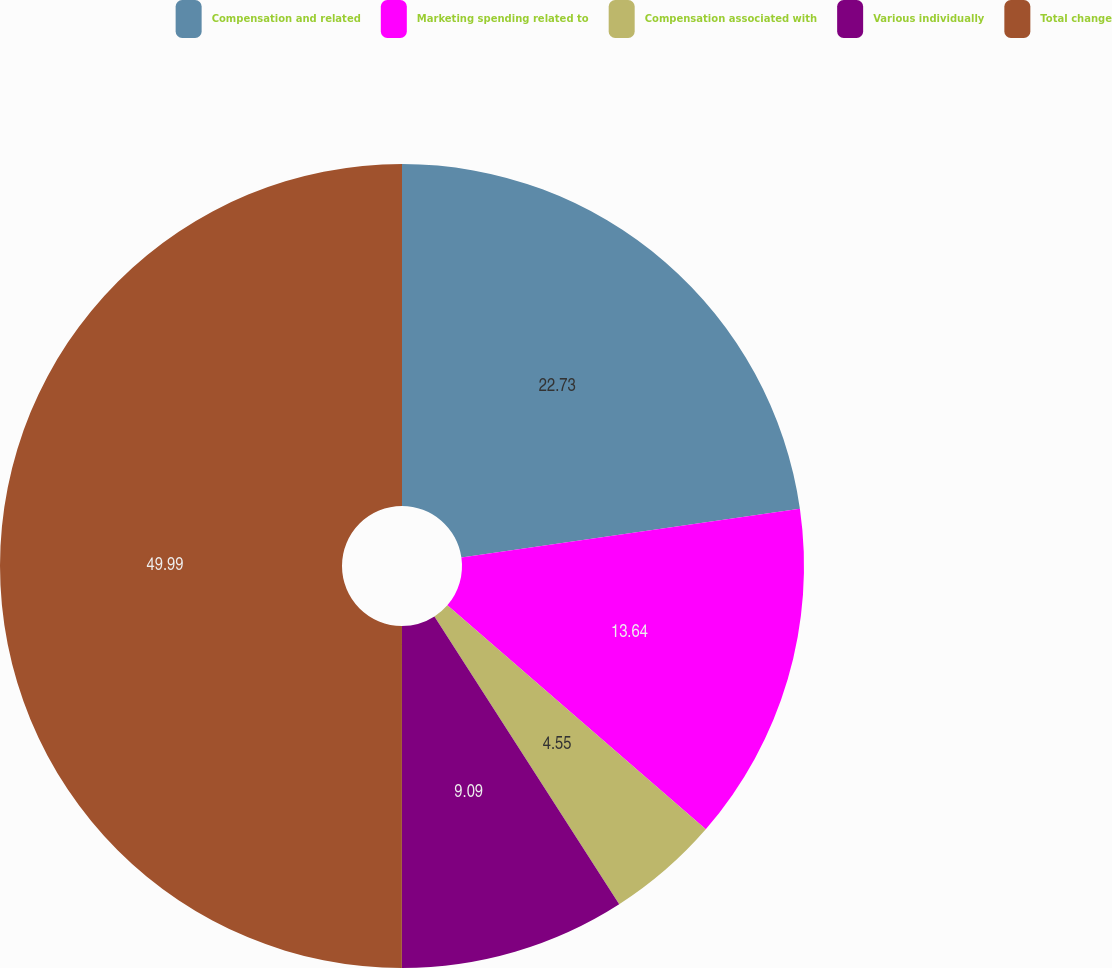<chart> <loc_0><loc_0><loc_500><loc_500><pie_chart><fcel>Compensation and related<fcel>Marketing spending related to<fcel>Compensation associated with<fcel>Various individually<fcel>Total change<nl><fcel>22.73%<fcel>13.64%<fcel>4.55%<fcel>9.09%<fcel>50.0%<nl></chart> 